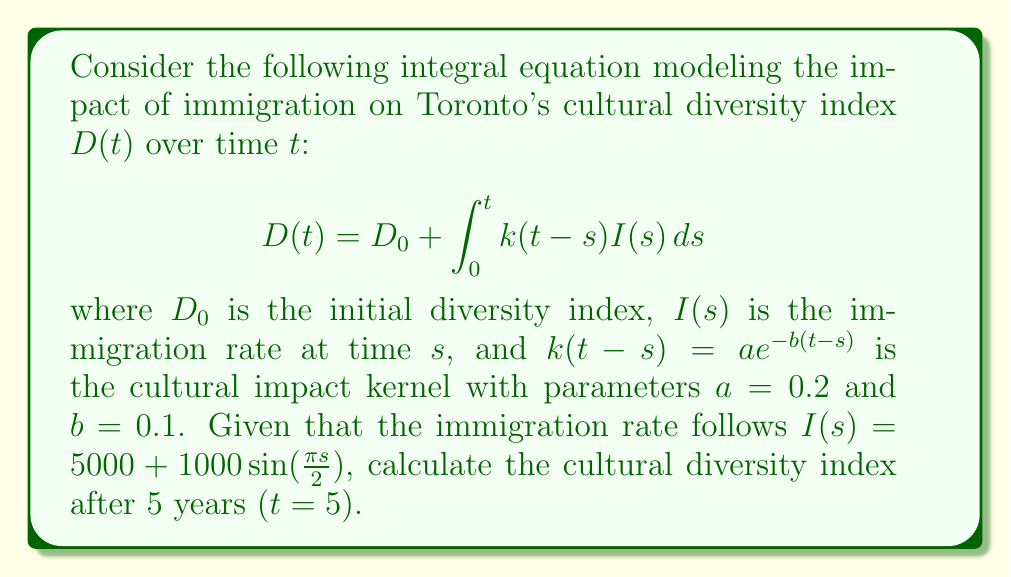Help me with this question. To solve this problem, we'll follow these steps:

1) First, let's substitute the given functions into the integral equation:

   $$D(5) = D_0 + \int_0^5 0.2e^{-0.1(5-s)}(5000 + 1000\sin(\frac{\pi s}{2}))ds$$

2) We can split this integral into two parts:

   $$D(5) = D_0 + 1000\int_0^5 0.2e^{-0.1(5-s)}ds + 200\int_0^5 e^{-0.1(5-s)}\sin(\frac{\pi s}{2})ds$$

3) For the first integral:

   $$\int_0^5 0.2e^{-0.1(5-s)}ds = -2e^{-0.1(5-s)}|_0^5 = -2(1-e^{-0.5}) = 2(e^{-0.5}-1)$$

4) For the second integral, we can use integration by parts:

   Let $u = \sin(\frac{\pi s}{2})$, $dv = e^{-0.1(5-s)}ds$
   Then $du = \frac{\pi}{2}\cos(\frac{\pi s}{2})ds$, $v = -10e^{-0.1(5-s)}$

   $$\int_0^5 e^{-0.1(5-s)}\sin(\frac{\pi s}{2})ds = -10\sin(\frac{\pi s}{2})e^{-0.1(5-s)}|_0^5 + 5\pi\int_0^5 e^{-0.1(5-s)}\cos(\frac{\pi s}{2})ds$$

   $$= -10\sin(\frac{5\pi}{2}) + 10\cdot0 + 5\pi\int_0^5 e^{-0.1(5-s)}\cos(\frac{\pi s}{2})ds$$

5) The remaining integral can be solved similarly:

   $$5\pi\int_0^5 e^{-0.1(5-s)}\cos(\frac{\pi s}{2})ds = 50\pi\cos(\frac{\pi s}{2})e^{-0.1(5-s)}|_0^5 + 25\pi^2\int_0^5 e^{-0.1(5-s)}\sin(\frac{\pi s}{2})ds$$

   $$= 50\pi\cos(\frac{5\pi}{2}) - 50\pi e^{-0.5} + 25\pi^2\int_0^5 e^{-0.1(5-s)}\sin(\frac{\pi s}{2})ds$$

6) Combining the results:

   $$D(5) = D_0 + 1000[2(e^{-0.5}-1)] + 200[-10\sin(\frac{5\pi}{2}) + 50\pi\cos(\frac{5\pi}{2}) - 50\pi e^{-0.5} + 25\pi^2\int_0^5 e^{-0.1(5-s)}\sin(\frac{\pi s}{2})ds]$$

7) Solving for the integral:

   $$\int_0^5 e^{-0.1(5-s)}\sin(\frac{\pi s}{2})ds = \frac{-10\sin(\frac{5\pi}{2}) + 50\pi\cos(\frac{5\pi}{2}) - 50\pi e^{-0.5}}{1 - 25\pi^2}$$

8) Substituting this back and simplifying:

   $$D(5) = D_0 + 2000(e^{-0.5}-1) + \frac{4000[-10\sin(\frac{5\pi}{2}) + 50\pi\cos(\frac{5\pi}{2}) - 50\pi e^{-0.5}]}{1 - 25\pi^2}$$
Answer: $$D(5) = D_0 + 2000(e^{-0.5}-1) + \frac{4000[-10\sin(\frac{5\pi}{2}) + 50\pi\cos(\frac{5\pi}{2}) - 50\pi e^{-0.5}]}{1 - 25\pi^2}$$ 